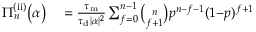<formula> <loc_0><loc_0><loc_500><loc_500>\begin{array} { r l } { \Pi _ { n } ^ { ( i i ) } \left ( \alpha \right ) } & = \frac { \tau _ { m } } { \tau _ { d } | \alpha | ^ { 2 } } \sum _ { f = 0 } ^ { n - 1 } \binom { n } { f + 1 } p ^ { n - f - 1 } ( 1 { - } p ) ^ { f + 1 } } \end{array}</formula> 